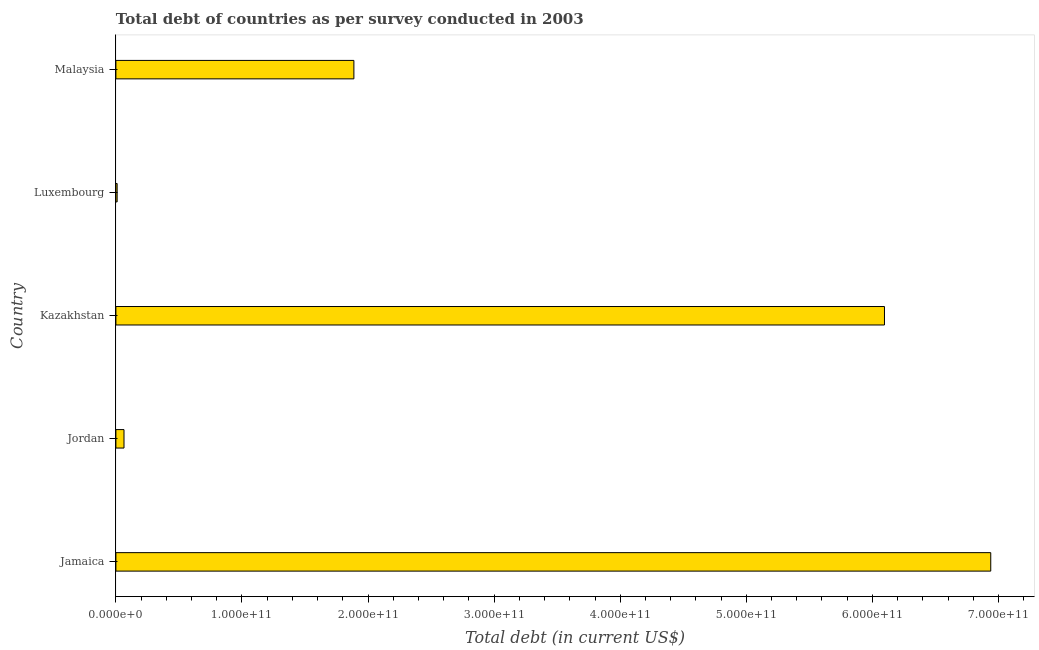Does the graph contain any zero values?
Make the answer very short. No. What is the title of the graph?
Make the answer very short. Total debt of countries as per survey conducted in 2003. What is the label or title of the X-axis?
Give a very brief answer. Total debt (in current US$). What is the total debt in Kazakhstan?
Offer a terse response. 6.10e+11. Across all countries, what is the maximum total debt?
Your answer should be very brief. 6.94e+11. Across all countries, what is the minimum total debt?
Give a very brief answer. 9.94e+08. In which country was the total debt maximum?
Make the answer very short. Jamaica. In which country was the total debt minimum?
Give a very brief answer. Luxembourg. What is the sum of the total debt?
Provide a succinct answer. 1.50e+12. What is the difference between the total debt in Jamaica and Jordan?
Give a very brief answer. 6.87e+11. What is the average total debt per country?
Ensure brevity in your answer.  3.00e+11. What is the median total debt?
Your answer should be compact. 1.89e+11. What is the ratio of the total debt in Jamaica to that in Malaysia?
Make the answer very short. 3.68. Is the difference between the total debt in Kazakhstan and Malaysia greater than the difference between any two countries?
Provide a succinct answer. No. What is the difference between the highest and the second highest total debt?
Offer a terse response. 8.43e+1. What is the difference between the highest and the lowest total debt?
Make the answer very short. 6.93e+11. How many bars are there?
Provide a succinct answer. 5. Are all the bars in the graph horizontal?
Your answer should be compact. Yes. What is the difference between two consecutive major ticks on the X-axis?
Ensure brevity in your answer.  1.00e+11. What is the Total debt (in current US$) of Jamaica?
Provide a succinct answer. 6.94e+11. What is the Total debt (in current US$) in Jordan?
Offer a very short reply. 6.43e+09. What is the Total debt (in current US$) of Kazakhstan?
Provide a short and direct response. 6.10e+11. What is the Total debt (in current US$) of Luxembourg?
Keep it short and to the point. 9.94e+08. What is the Total debt (in current US$) in Malaysia?
Your response must be concise. 1.89e+11. What is the difference between the Total debt (in current US$) in Jamaica and Jordan?
Provide a succinct answer. 6.87e+11. What is the difference between the Total debt (in current US$) in Jamaica and Kazakhstan?
Give a very brief answer. 8.43e+1. What is the difference between the Total debt (in current US$) in Jamaica and Luxembourg?
Provide a succinct answer. 6.93e+11. What is the difference between the Total debt (in current US$) in Jamaica and Malaysia?
Your answer should be compact. 5.05e+11. What is the difference between the Total debt (in current US$) in Jordan and Kazakhstan?
Your response must be concise. -6.03e+11. What is the difference between the Total debt (in current US$) in Jordan and Luxembourg?
Your response must be concise. 5.43e+09. What is the difference between the Total debt (in current US$) in Jordan and Malaysia?
Keep it short and to the point. -1.82e+11. What is the difference between the Total debt (in current US$) in Kazakhstan and Luxembourg?
Make the answer very short. 6.09e+11. What is the difference between the Total debt (in current US$) in Kazakhstan and Malaysia?
Your response must be concise. 4.21e+11. What is the difference between the Total debt (in current US$) in Luxembourg and Malaysia?
Give a very brief answer. -1.88e+11. What is the ratio of the Total debt (in current US$) in Jamaica to that in Jordan?
Make the answer very short. 107.95. What is the ratio of the Total debt (in current US$) in Jamaica to that in Kazakhstan?
Provide a short and direct response. 1.14. What is the ratio of the Total debt (in current US$) in Jamaica to that in Luxembourg?
Your answer should be very brief. 697.87. What is the ratio of the Total debt (in current US$) in Jamaica to that in Malaysia?
Make the answer very short. 3.68. What is the ratio of the Total debt (in current US$) in Jordan to that in Kazakhstan?
Offer a very short reply. 0.01. What is the ratio of the Total debt (in current US$) in Jordan to that in Luxembourg?
Your response must be concise. 6.46. What is the ratio of the Total debt (in current US$) in Jordan to that in Malaysia?
Your response must be concise. 0.03. What is the ratio of the Total debt (in current US$) in Kazakhstan to that in Luxembourg?
Offer a terse response. 613.09. What is the ratio of the Total debt (in current US$) in Kazakhstan to that in Malaysia?
Your answer should be compact. 3.23. What is the ratio of the Total debt (in current US$) in Luxembourg to that in Malaysia?
Make the answer very short. 0.01. 